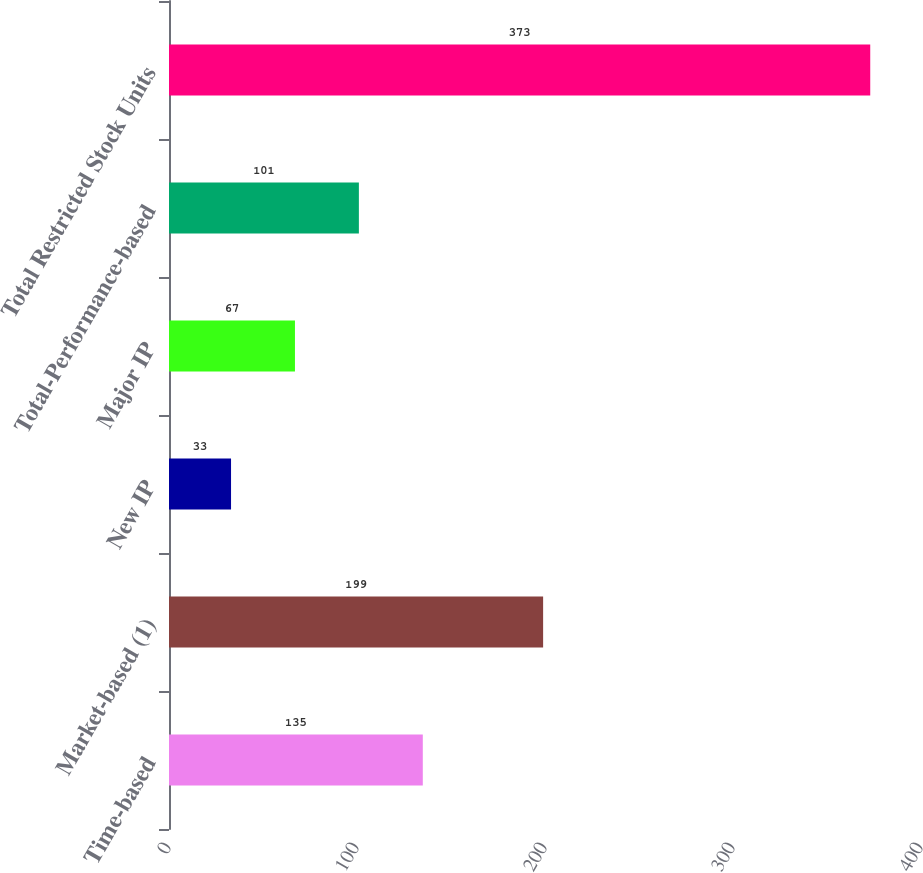<chart> <loc_0><loc_0><loc_500><loc_500><bar_chart><fcel>Time-based<fcel>Market-based (1)<fcel>New IP<fcel>Major IP<fcel>Total-Performance-based<fcel>Total Restricted Stock Units<nl><fcel>135<fcel>199<fcel>33<fcel>67<fcel>101<fcel>373<nl></chart> 